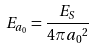Convert formula to latex. <formula><loc_0><loc_0><loc_500><loc_500>E _ { a _ { 0 } } = \frac { E _ { S } } { 4 \pi { a _ { 0 } } ^ { 2 } }</formula> 